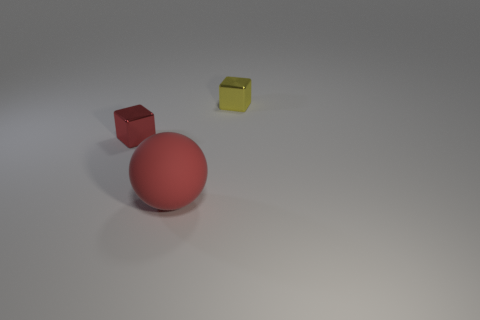Are there any other things that have the same size as the ball?
Your response must be concise. No. There is a metallic thing that is behind the red metal thing; does it have the same size as the red metal cube?
Ensure brevity in your answer.  Yes. What number of things are in front of the tiny yellow cube and behind the big red matte ball?
Your answer should be very brief. 1. How big is the thing that is behind the small thing in front of the yellow thing?
Offer a very short reply. Small. Is the number of red metallic objects behind the red rubber sphere less than the number of tiny red things on the left side of the red shiny thing?
Make the answer very short. No. Is the color of the small metallic cube right of the rubber thing the same as the small metal block that is to the left of the yellow thing?
Your answer should be very brief. No. There is a thing that is both to the left of the yellow block and behind the red sphere; what material is it?
Your answer should be compact. Metal. Is there a large purple shiny cylinder?
Ensure brevity in your answer.  No. There is a thing that is the same material as the red cube; what is its shape?
Your response must be concise. Cube. Does the big red rubber object have the same shape as the small thing left of the matte object?
Offer a very short reply. No. 